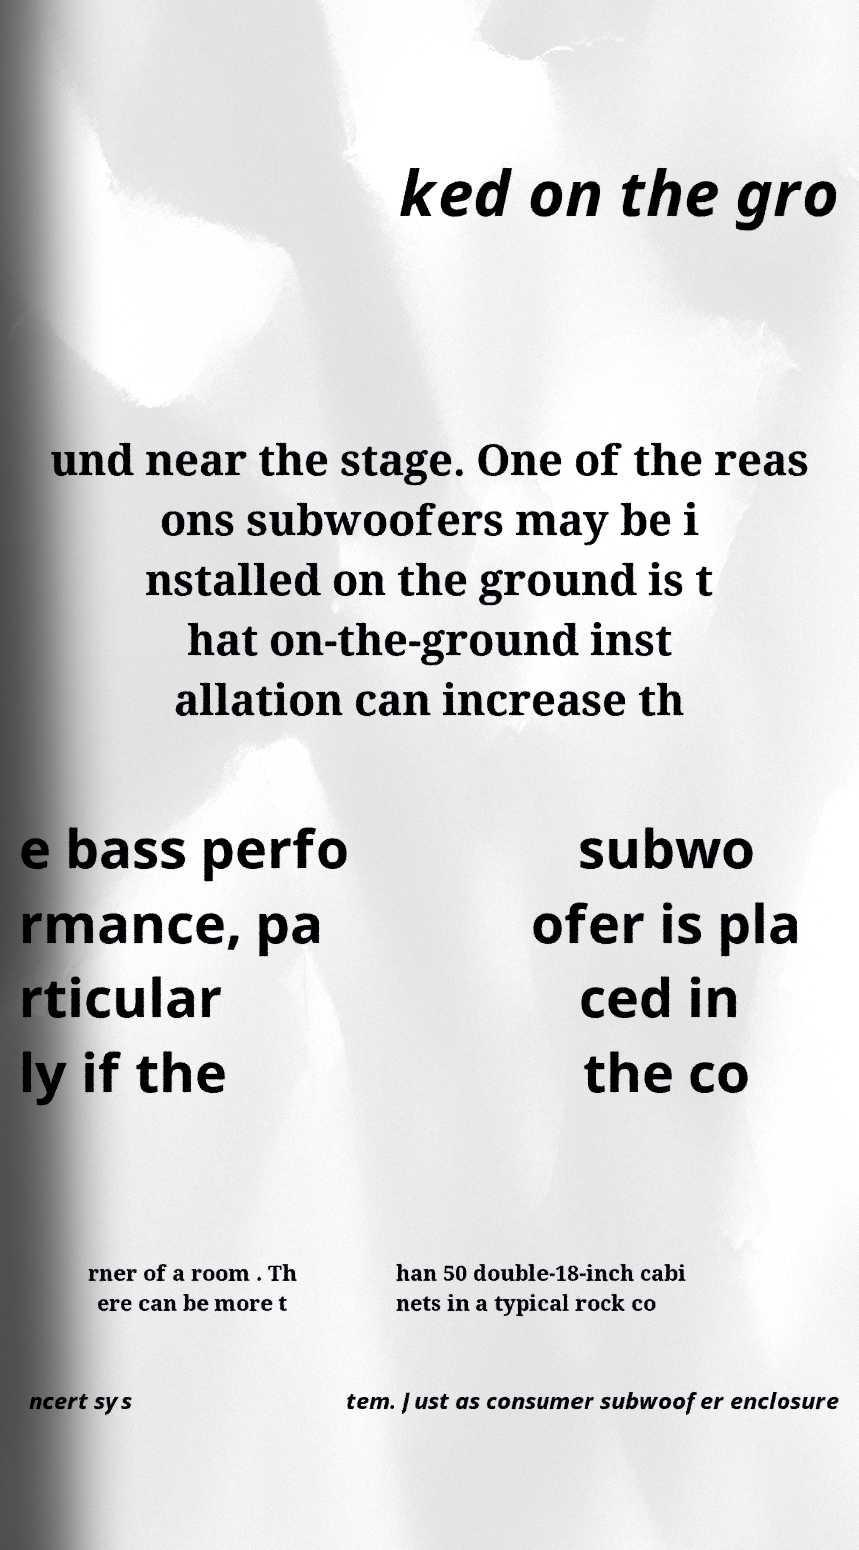Can you read and provide the text displayed in the image?This photo seems to have some interesting text. Can you extract and type it out for me? ked on the gro und near the stage. One of the reas ons subwoofers may be i nstalled on the ground is t hat on-the-ground inst allation can increase th e bass perfo rmance, pa rticular ly if the subwo ofer is pla ced in the co rner of a room . Th ere can be more t han 50 double-18-inch cabi nets in a typical rock co ncert sys tem. Just as consumer subwoofer enclosure 